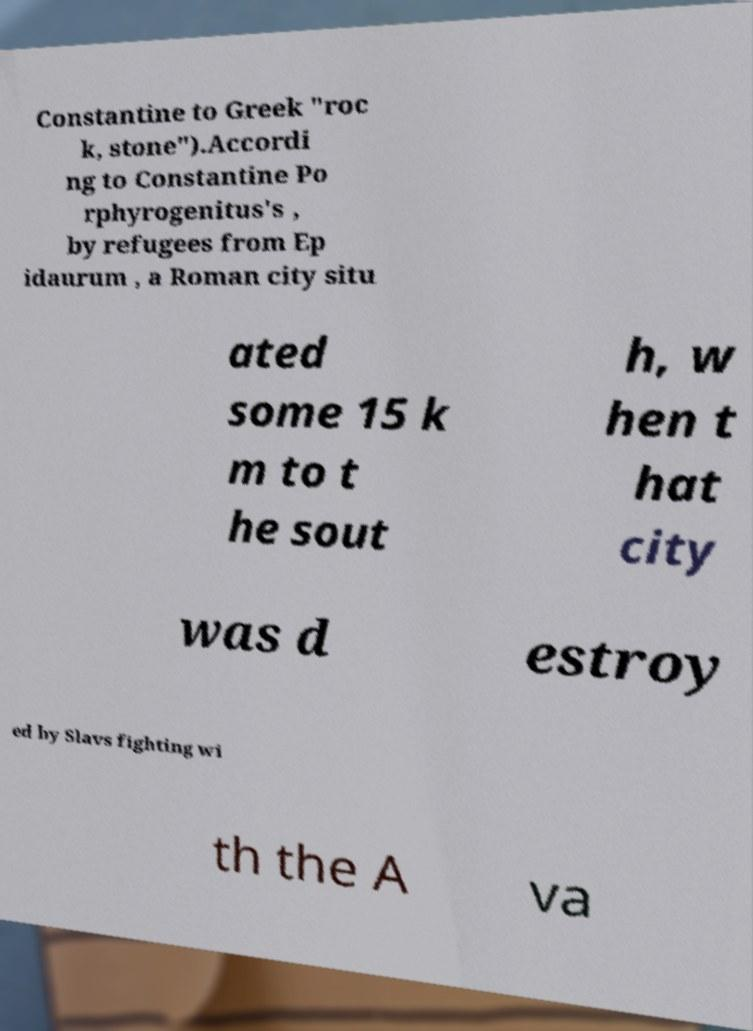Can you accurately transcribe the text from the provided image for me? Constantine to Greek "roc k, stone").Accordi ng to Constantine Po rphyrogenitus's , by refugees from Ep idaurum , a Roman city situ ated some 15 k m to t he sout h, w hen t hat city was d estroy ed by Slavs fighting wi th the A va 